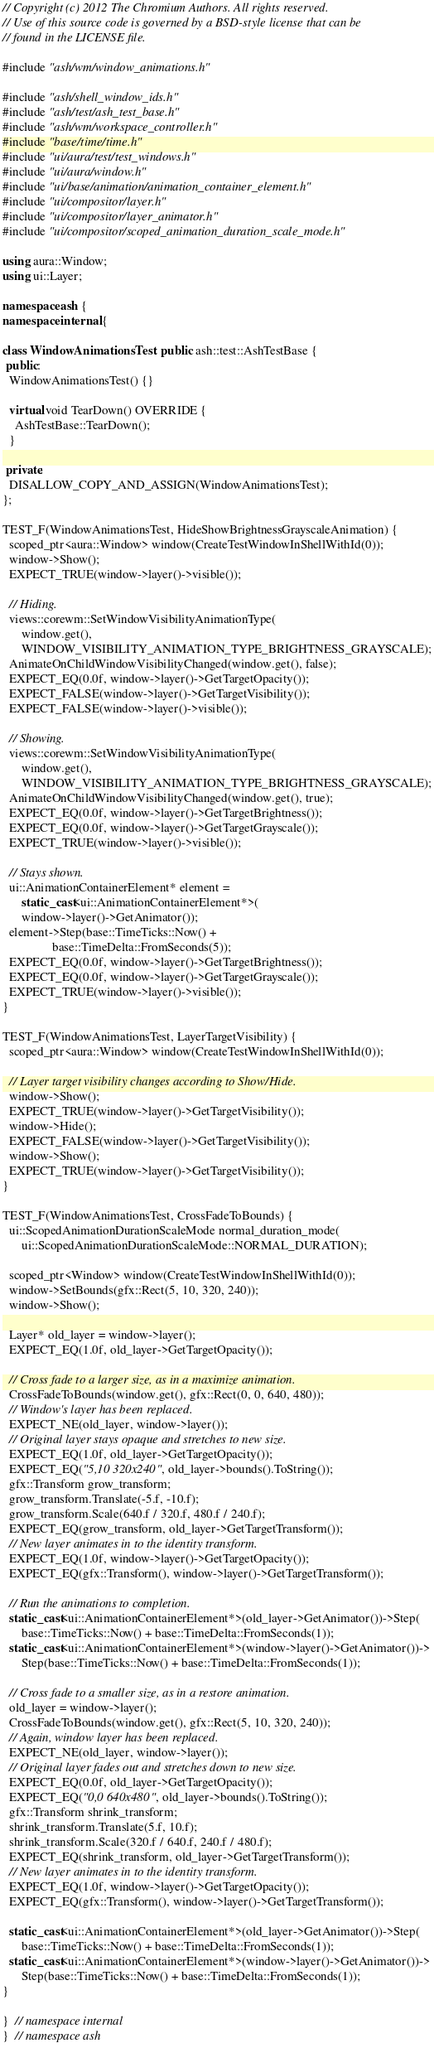Convert code to text. <code><loc_0><loc_0><loc_500><loc_500><_C++_>// Copyright (c) 2012 The Chromium Authors. All rights reserved.
// Use of this source code is governed by a BSD-style license that can be
// found in the LICENSE file.

#include "ash/wm/window_animations.h"

#include "ash/shell_window_ids.h"
#include "ash/test/ash_test_base.h"
#include "ash/wm/workspace_controller.h"
#include "base/time/time.h"
#include "ui/aura/test/test_windows.h"
#include "ui/aura/window.h"
#include "ui/base/animation/animation_container_element.h"
#include "ui/compositor/layer.h"
#include "ui/compositor/layer_animator.h"
#include "ui/compositor/scoped_animation_duration_scale_mode.h"

using aura::Window;
using ui::Layer;

namespace ash {
namespace internal {

class WindowAnimationsTest : public ash::test::AshTestBase {
 public:
  WindowAnimationsTest() {}

  virtual void TearDown() OVERRIDE {
    AshTestBase::TearDown();
  }

 private:
  DISALLOW_COPY_AND_ASSIGN(WindowAnimationsTest);
};

TEST_F(WindowAnimationsTest, HideShowBrightnessGrayscaleAnimation) {
  scoped_ptr<aura::Window> window(CreateTestWindowInShellWithId(0));
  window->Show();
  EXPECT_TRUE(window->layer()->visible());

  // Hiding.
  views::corewm::SetWindowVisibilityAnimationType(
      window.get(),
      WINDOW_VISIBILITY_ANIMATION_TYPE_BRIGHTNESS_GRAYSCALE);
  AnimateOnChildWindowVisibilityChanged(window.get(), false);
  EXPECT_EQ(0.0f, window->layer()->GetTargetOpacity());
  EXPECT_FALSE(window->layer()->GetTargetVisibility());
  EXPECT_FALSE(window->layer()->visible());

  // Showing.
  views::corewm::SetWindowVisibilityAnimationType(
      window.get(),
      WINDOW_VISIBILITY_ANIMATION_TYPE_BRIGHTNESS_GRAYSCALE);
  AnimateOnChildWindowVisibilityChanged(window.get(), true);
  EXPECT_EQ(0.0f, window->layer()->GetTargetBrightness());
  EXPECT_EQ(0.0f, window->layer()->GetTargetGrayscale());
  EXPECT_TRUE(window->layer()->visible());

  // Stays shown.
  ui::AnimationContainerElement* element =
      static_cast<ui::AnimationContainerElement*>(
      window->layer()->GetAnimator());
  element->Step(base::TimeTicks::Now() +
                base::TimeDelta::FromSeconds(5));
  EXPECT_EQ(0.0f, window->layer()->GetTargetBrightness());
  EXPECT_EQ(0.0f, window->layer()->GetTargetGrayscale());
  EXPECT_TRUE(window->layer()->visible());
}

TEST_F(WindowAnimationsTest, LayerTargetVisibility) {
  scoped_ptr<aura::Window> window(CreateTestWindowInShellWithId(0));

  // Layer target visibility changes according to Show/Hide.
  window->Show();
  EXPECT_TRUE(window->layer()->GetTargetVisibility());
  window->Hide();
  EXPECT_FALSE(window->layer()->GetTargetVisibility());
  window->Show();
  EXPECT_TRUE(window->layer()->GetTargetVisibility());
}

TEST_F(WindowAnimationsTest, CrossFadeToBounds) {
  ui::ScopedAnimationDurationScaleMode normal_duration_mode(
      ui::ScopedAnimationDurationScaleMode::NORMAL_DURATION);

  scoped_ptr<Window> window(CreateTestWindowInShellWithId(0));
  window->SetBounds(gfx::Rect(5, 10, 320, 240));
  window->Show();

  Layer* old_layer = window->layer();
  EXPECT_EQ(1.0f, old_layer->GetTargetOpacity());

  // Cross fade to a larger size, as in a maximize animation.
  CrossFadeToBounds(window.get(), gfx::Rect(0, 0, 640, 480));
  // Window's layer has been replaced.
  EXPECT_NE(old_layer, window->layer());
  // Original layer stays opaque and stretches to new size.
  EXPECT_EQ(1.0f, old_layer->GetTargetOpacity());
  EXPECT_EQ("5,10 320x240", old_layer->bounds().ToString());
  gfx::Transform grow_transform;
  grow_transform.Translate(-5.f, -10.f);
  grow_transform.Scale(640.f / 320.f, 480.f / 240.f);
  EXPECT_EQ(grow_transform, old_layer->GetTargetTransform());
  // New layer animates in to the identity transform.
  EXPECT_EQ(1.0f, window->layer()->GetTargetOpacity());
  EXPECT_EQ(gfx::Transform(), window->layer()->GetTargetTransform());

  // Run the animations to completion.
  static_cast<ui::AnimationContainerElement*>(old_layer->GetAnimator())->Step(
      base::TimeTicks::Now() + base::TimeDelta::FromSeconds(1));
  static_cast<ui::AnimationContainerElement*>(window->layer()->GetAnimator())->
      Step(base::TimeTicks::Now() + base::TimeDelta::FromSeconds(1));

  // Cross fade to a smaller size, as in a restore animation.
  old_layer = window->layer();
  CrossFadeToBounds(window.get(), gfx::Rect(5, 10, 320, 240));
  // Again, window layer has been replaced.
  EXPECT_NE(old_layer, window->layer());
  // Original layer fades out and stretches down to new size.
  EXPECT_EQ(0.0f, old_layer->GetTargetOpacity());
  EXPECT_EQ("0,0 640x480", old_layer->bounds().ToString());
  gfx::Transform shrink_transform;
  shrink_transform.Translate(5.f, 10.f);
  shrink_transform.Scale(320.f / 640.f, 240.f / 480.f);
  EXPECT_EQ(shrink_transform, old_layer->GetTargetTransform());
  // New layer animates in to the identity transform.
  EXPECT_EQ(1.0f, window->layer()->GetTargetOpacity());
  EXPECT_EQ(gfx::Transform(), window->layer()->GetTargetTransform());

  static_cast<ui::AnimationContainerElement*>(old_layer->GetAnimator())->Step(
      base::TimeTicks::Now() + base::TimeDelta::FromSeconds(1));
  static_cast<ui::AnimationContainerElement*>(window->layer()->GetAnimator())->
      Step(base::TimeTicks::Now() + base::TimeDelta::FromSeconds(1));
}

}  // namespace internal
}  // namespace ash
</code> 